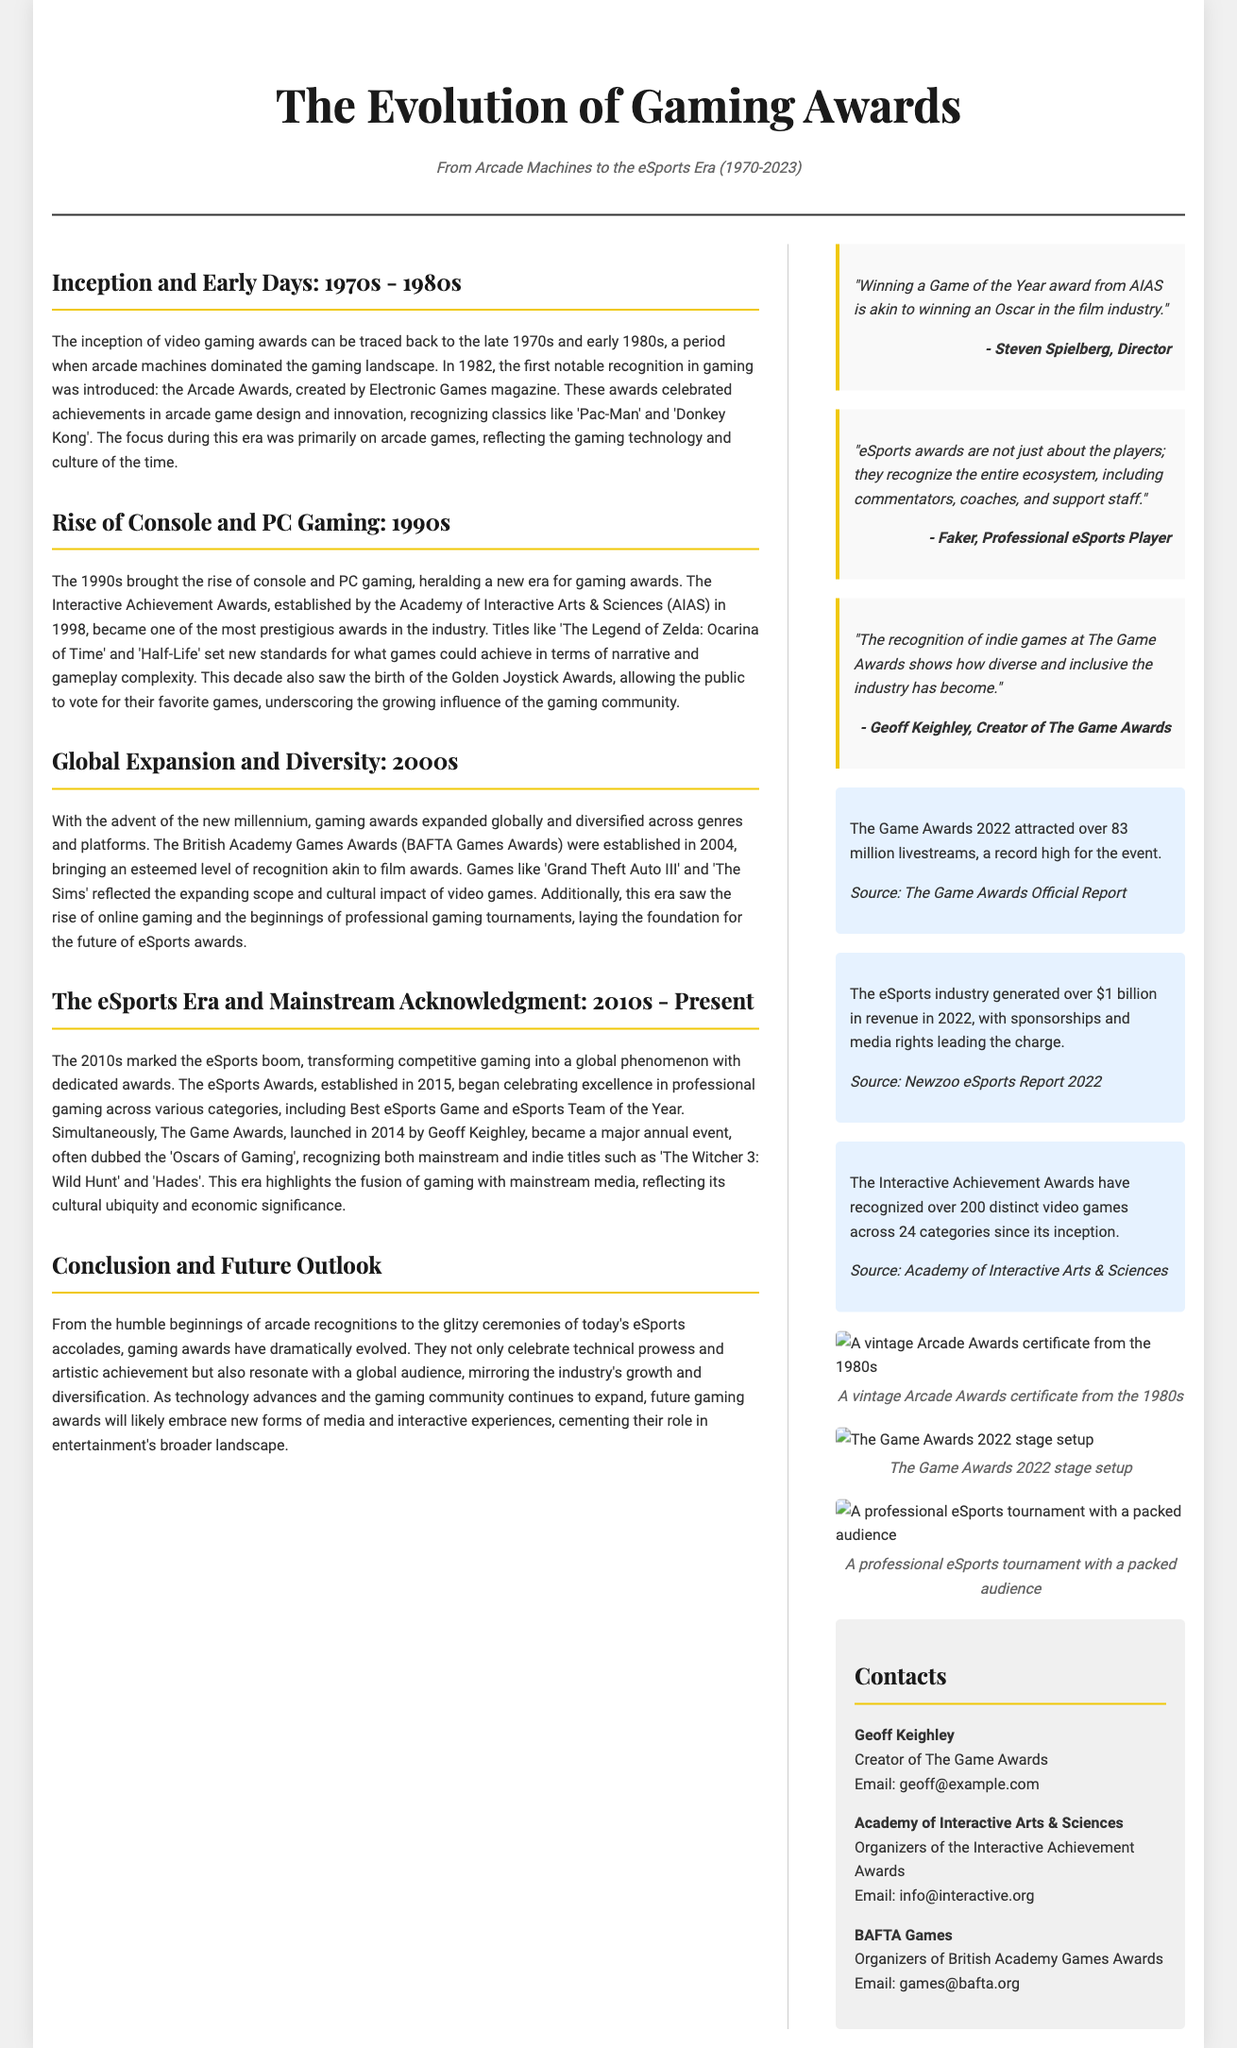What year were the Arcade Awards introduced? The document states that the Arcade Awards were created in 1982.
Answer: 1982 Which games were recognized in the early days of gaming awards? The document mentions classics like 'Pac-Man' and 'Donkey Kong' as recognized games.
Answer: 'Pac-Man' and 'Donkey Kong' What prestigious awards were established in 1998? The document refers to the Interactive Achievement Awards established by AIAS.
Answer: Interactive Achievement Awards How many livestreams did The Game Awards 2022 attract? The document states that The Game Awards 2022 attracted over 83 million livestreams.
Answer: 83 million What is the significance of the eSports Awards established in 2015? The document explains that the eSports Awards celebrate excellence in professional gaming.
Answer: Celebrate excellence in professional gaming Which game is mentioned as an example of recognition in the 2010s? The document refers to 'The Witcher 3: Wild Hunt' as a recognized title in this era.
Answer: 'The Witcher 3: Wild Hunt' How did the recognition of indie games evolve? The document notes that recognition at The Game Awards shows diversity and inclusion in the industry.
Answer: Diversity and inclusion What organization recognizes the Interactive Achievement Awards? The document specifies that the Academy of Interactive Arts & Sciences organizes these awards.
Answer: Academy of Interactive Arts & Sciences What genre did the British Academy Games Awards focus on? The document implies that it covers diverse genres and platforms in gaming.
Answer: Diverse genres and platforms 